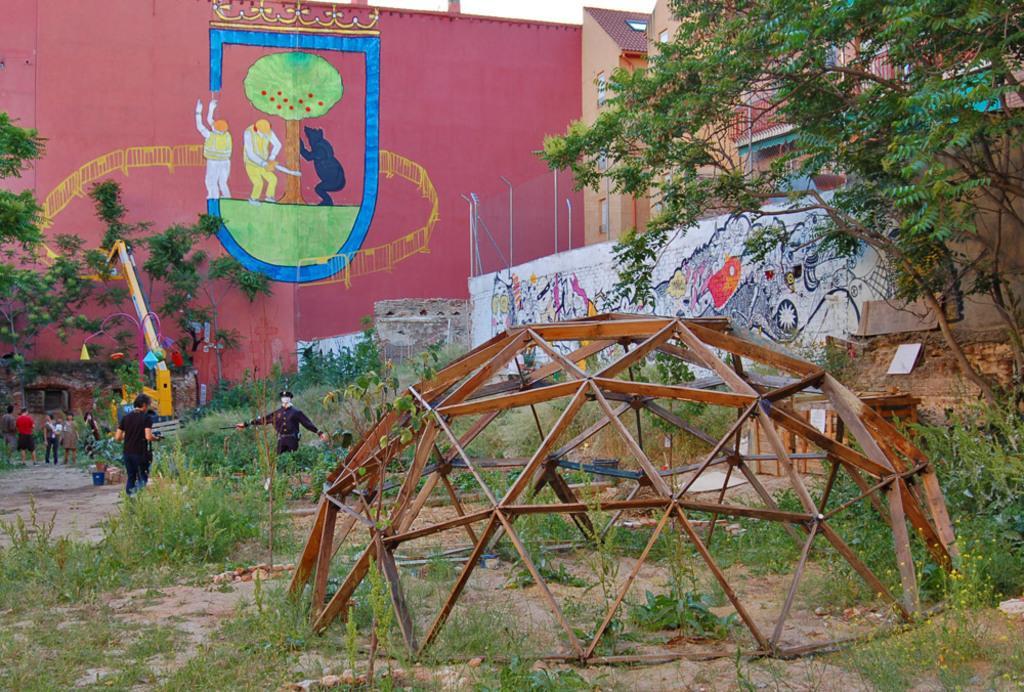How would you summarize this image in a sentence or two? In this image I can see the houses. I can see the paintings on the wall of the building. I can see a few people on the left side. I can see a statue. There is a metal structure on the right side. I can see the trees on the left side and the right side as well. 